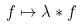Convert formula to latex. <formula><loc_0><loc_0><loc_500><loc_500>f \mapsto \lambda * f</formula> 